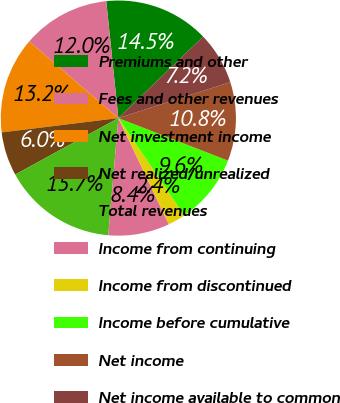Convert chart. <chart><loc_0><loc_0><loc_500><loc_500><pie_chart><fcel>Premiums and other<fcel>Fees and other revenues<fcel>Net investment income<fcel>Net realized/unrealized<fcel>Total revenues<fcel>Income from continuing<fcel>Income from discontinued<fcel>Income before cumulative<fcel>Net income<fcel>Net income available to common<nl><fcel>14.46%<fcel>12.05%<fcel>13.25%<fcel>6.03%<fcel>15.66%<fcel>8.43%<fcel>2.41%<fcel>9.64%<fcel>10.84%<fcel>7.23%<nl></chart> 